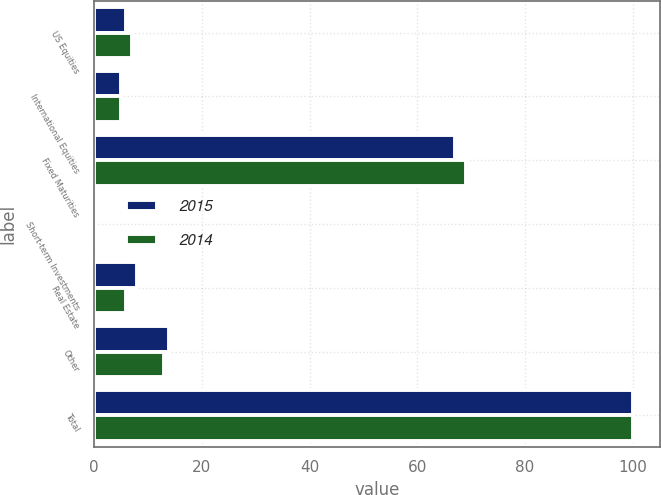Convert chart to OTSL. <chart><loc_0><loc_0><loc_500><loc_500><stacked_bar_chart><ecel><fcel>US Equities<fcel>International Equities<fcel>Fixed Maturities<fcel>Short-term Investments<fcel>Real Estate<fcel>Other<fcel>Total<nl><fcel>2015<fcel>6<fcel>5<fcel>67<fcel>0<fcel>8<fcel>14<fcel>100<nl><fcel>2014<fcel>7<fcel>5<fcel>69<fcel>0<fcel>6<fcel>13<fcel>100<nl></chart> 